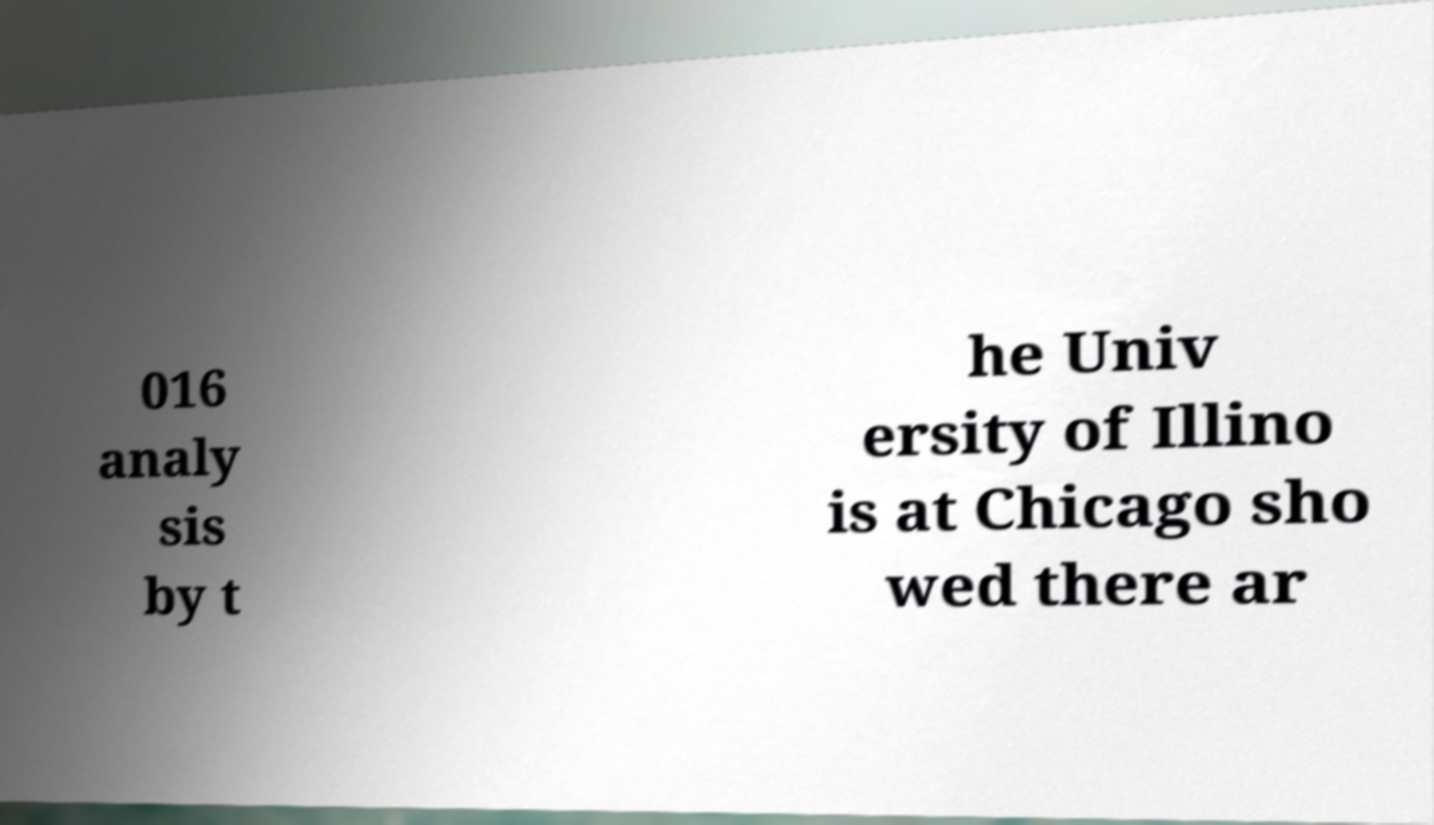What messages or text are displayed in this image? I need them in a readable, typed format. 016 analy sis by t he Univ ersity of Illino is at Chicago sho wed there ar 